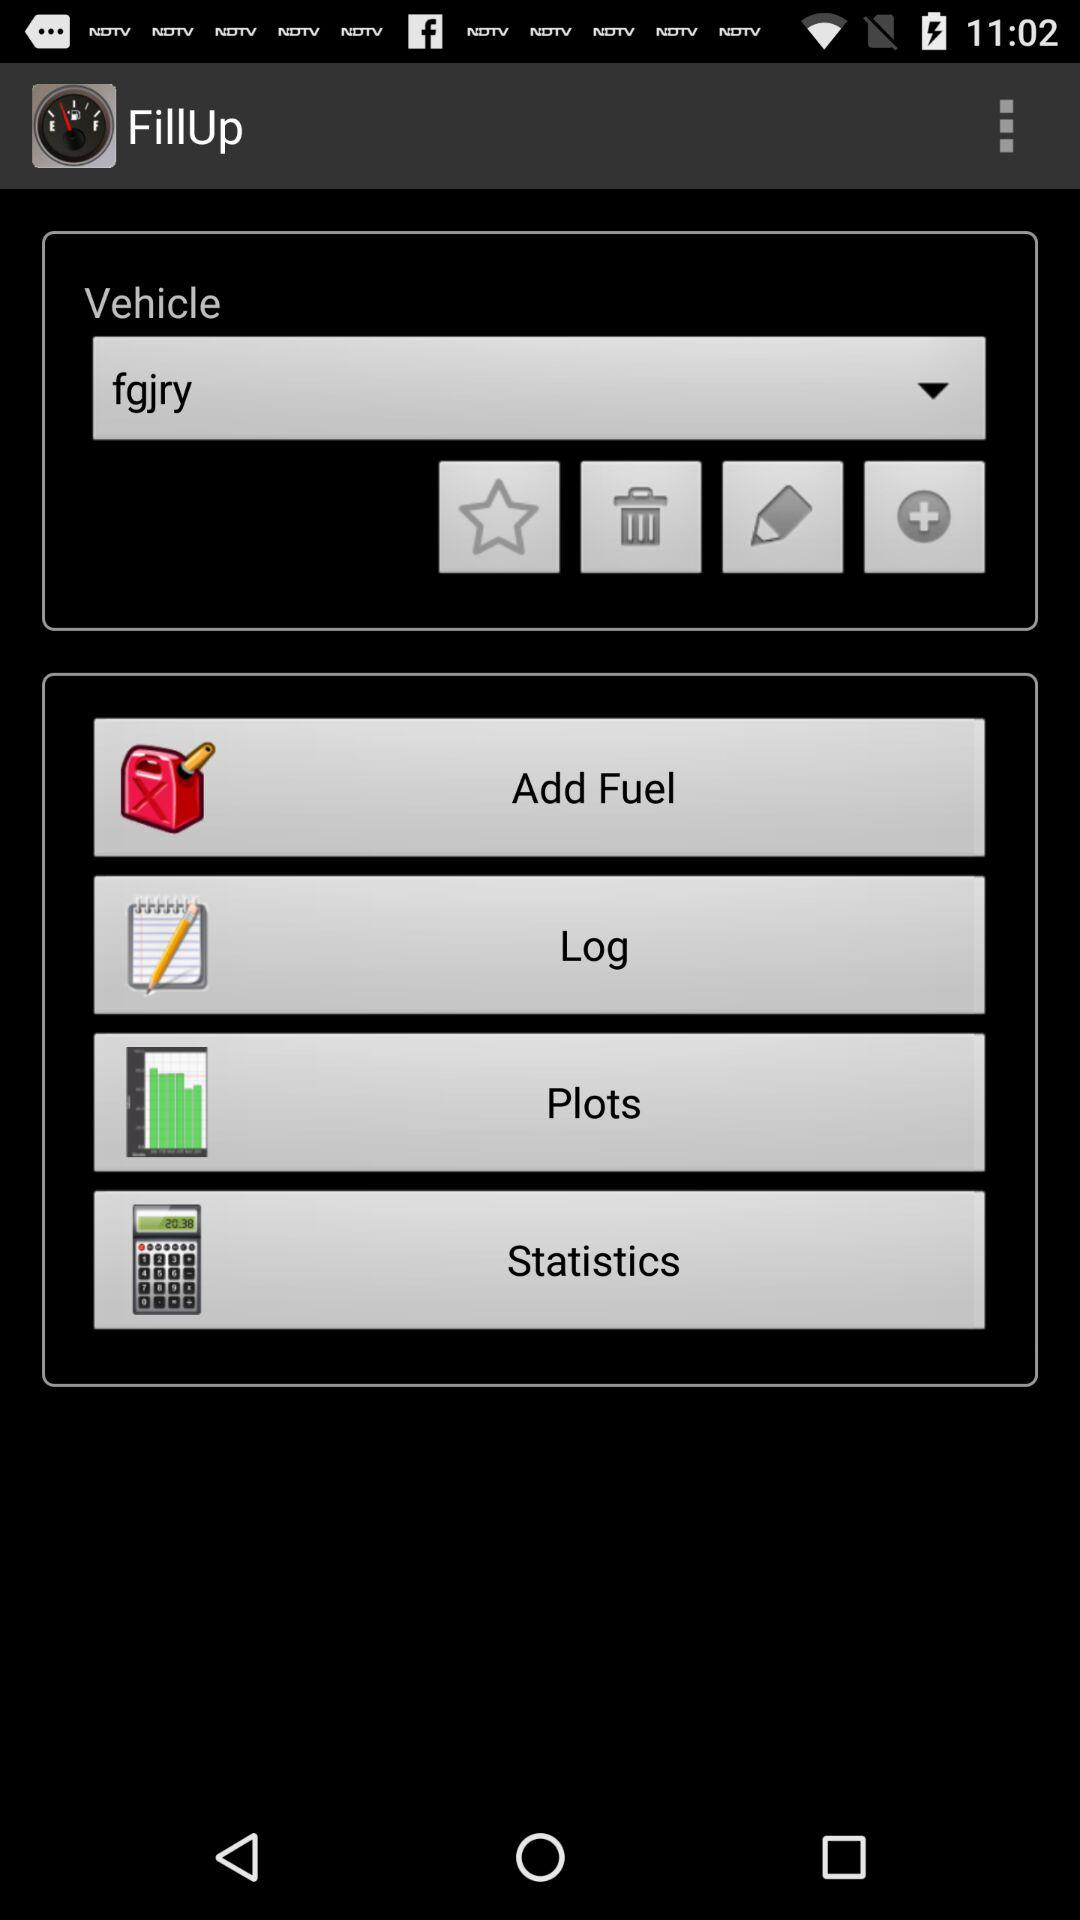What are the services available?
When the provided information is insufficient, respond with <no answer>. <no answer> 